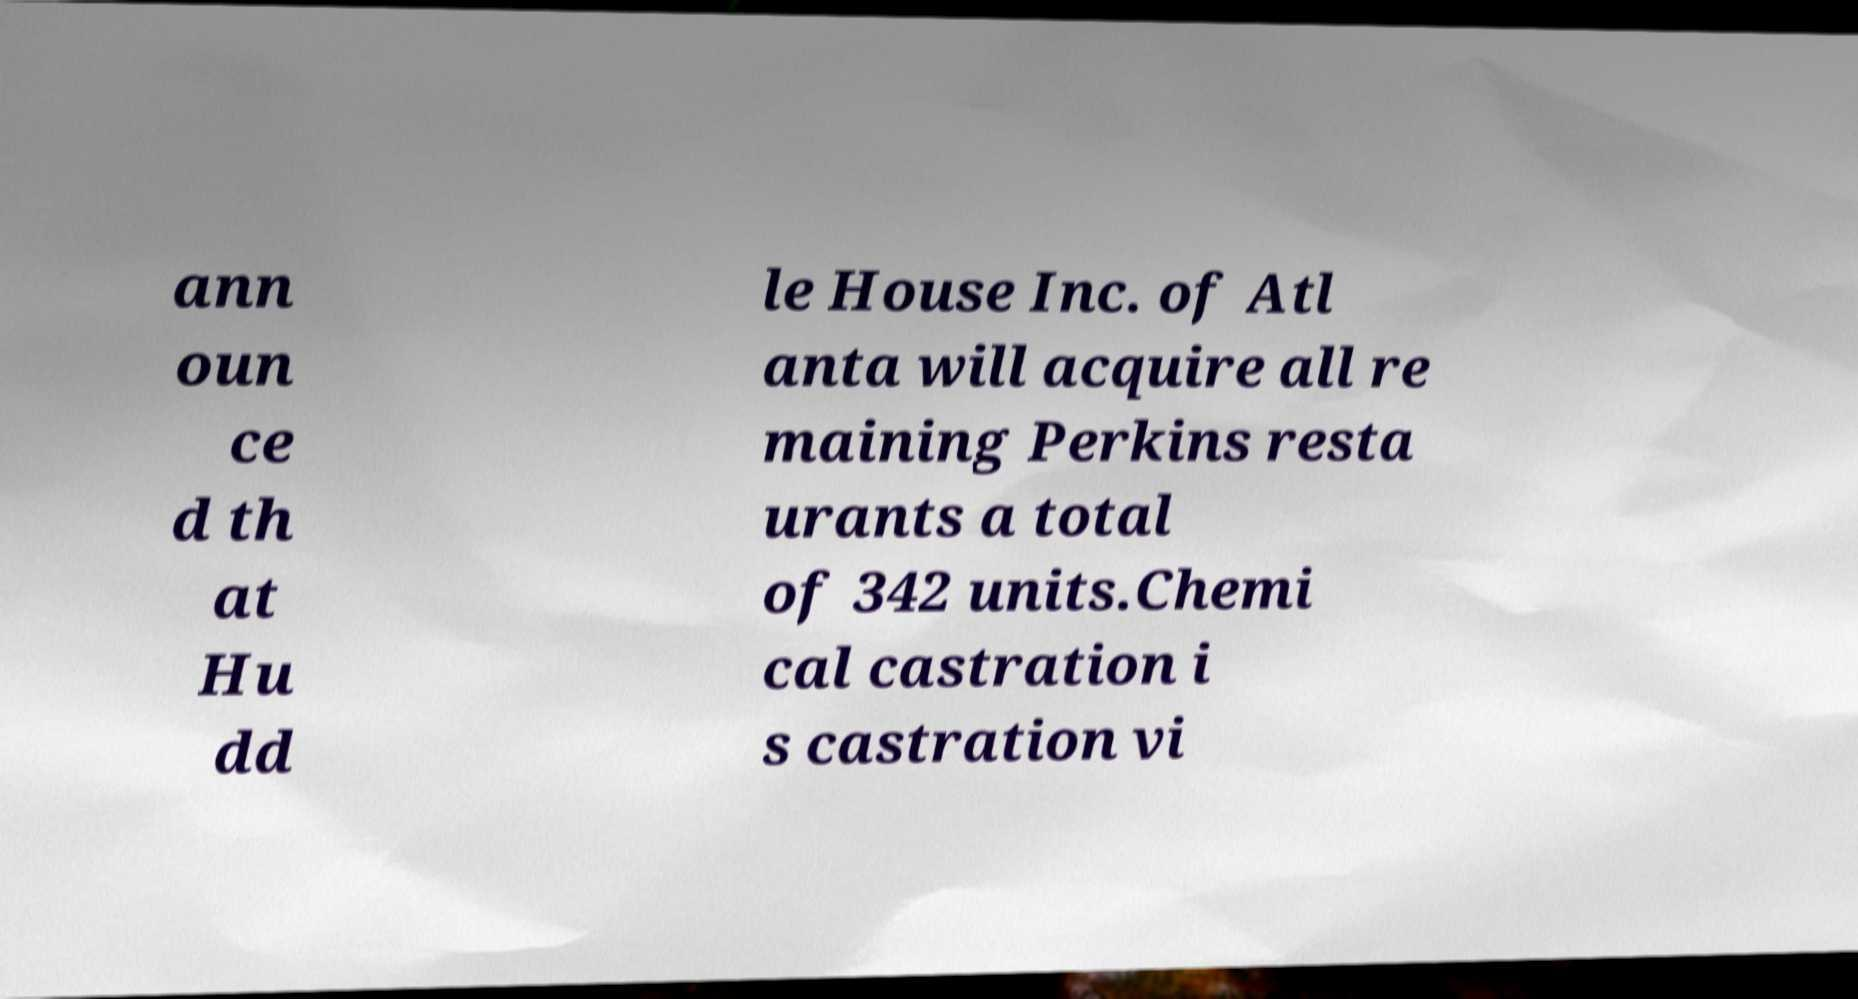There's text embedded in this image that I need extracted. Can you transcribe it verbatim? ann oun ce d th at Hu dd le House Inc. of Atl anta will acquire all re maining Perkins resta urants a total of 342 units.Chemi cal castration i s castration vi 